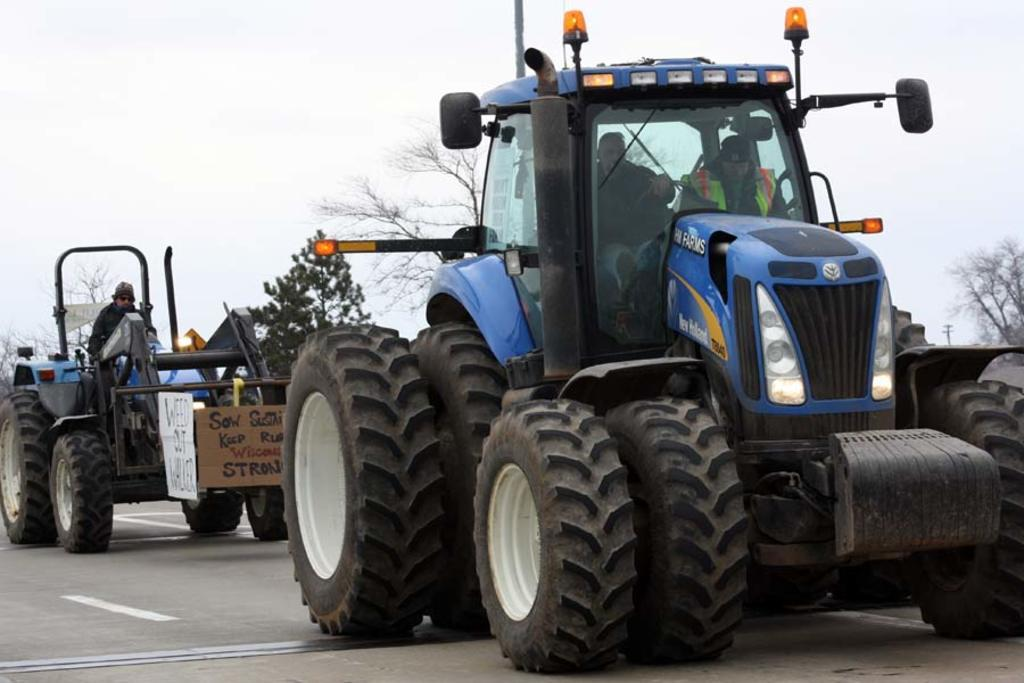How many tractors can be seen in the image? There are two tractors in the image. What color are the tractors? Both tractors are blue in color. What are the tractors doing in the image? The tractors are moving on a road. What can be seen in the background of the image? There are trees visible behind the vehicles. Is there a stranger walking through the cemetery during the rainstorm in the image? There is no cemetery, rainstorm, or stranger present in the image; it features two blue tractors moving on a road with trees in the background. 